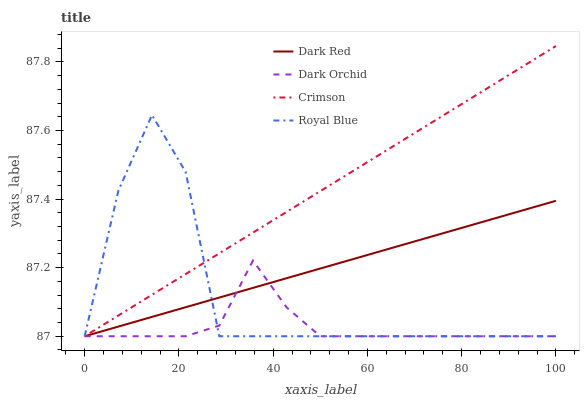Does Dark Orchid have the minimum area under the curve?
Answer yes or no. Yes. Does Crimson have the maximum area under the curve?
Answer yes or no. Yes. Does Dark Red have the minimum area under the curve?
Answer yes or no. No. Does Dark Red have the maximum area under the curve?
Answer yes or no. No. Is Dark Red the smoothest?
Answer yes or no. Yes. Is Royal Blue the roughest?
Answer yes or no. Yes. Is Dark Orchid the smoothest?
Answer yes or no. No. Is Dark Orchid the roughest?
Answer yes or no. No. Does Crimson have the lowest value?
Answer yes or no. Yes. Does Crimson have the highest value?
Answer yes or no. Yes. Does Dark Red have the highest value?
Answer yes or no. No. Does Crimson intersect Dark Red?
Answer yes or no. Yes. Is Crimson less than Dark Red?
Answer yes or no. No. Is Crimson greater than Dark Red?
Answer yes or no. No. 